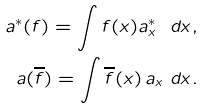<formula> <loc_0><loc_0><loc_500><loc_500>a ^ { * } ( f ) = \int f ( x ) a ^ { * } _ { x } \ d x , \\ a ( \overline { f } ) = \int \overline { f } ( x ) \, a _ { x } \ d x .</formula> 